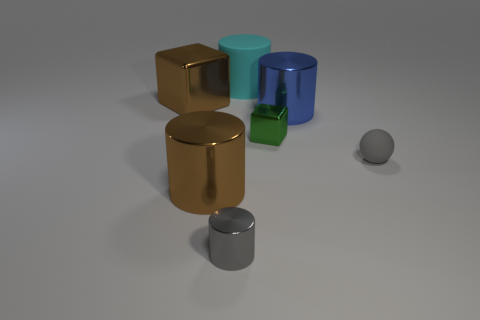Subtract all big cyan matte cylinders. How many cylinders are left? 3 Subtract all gray cylinders. How many cylinders are left? 3 Subtract 1 cylinders. How many cylinders are left? 3 Subtract all blocks. How many objects are left? 5 Add 1 large green rubber cubes. How many objects exist? 8 Subtract all green cylinders. Subtract all green cubes. How many cylinders are left? 4 Add 6 cyan things. How many cyan things exist? 7 Subtract 1 gray cylinders. How many objects are left? 6 Subtract all tiny gray cylinders. Subtract all gray matte things. How many objects are left? 5 Add 1 big matte things. How many big matte things are left? 2 